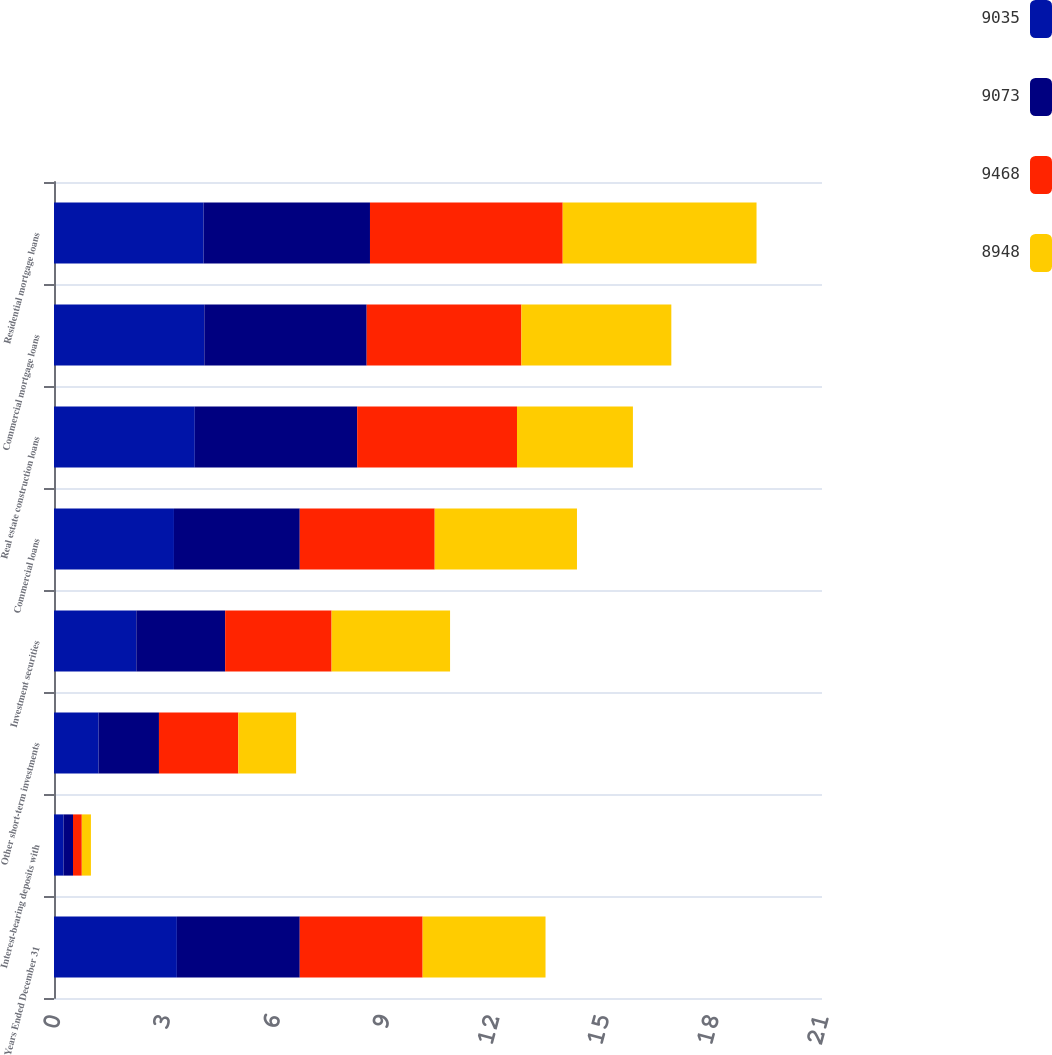Convert chart. <chart><loc_0><loc_0><loc_500><loc_500><stacked_bar_chart><ecel><fcel>Years Ended December 31<fcel>Interest-bearing deposits with<fcel>Other short-term investments<fcel>Investment securities<fcel>Commercial loans<fcel>Real estate construction loans<fcel>Commercial mortgage loans<fcel>Residential mortgage loans<nl><fcel>9035<fcel>3.36<fcel>0.26<fcel>1.22<fcel>2.25<fcel>3.28<fcel>3.85<fcel>4.11<fcel>4.09<nl><fcel>9073<fcel>3.36<fcel>0.26<fcel>1.65<fcel>2.43<fcel>3.44<fcel>4.44<fcel>4.44<fcel>4.55<nl><fcel>9468<fcel>3.36<fcel>0.24<fcel>2.17<fcel>2.91<fcel>3.69<fcel>4.37<fcel>4.23<fcel>5.27<nl><fcel>8948<fcel>3.36<fcel>0.25<fcel>1.58<fcel>3.24<fcel>3.89<fcel>3.17<fcel>4.1<fcel>5.3<nl></chart> 